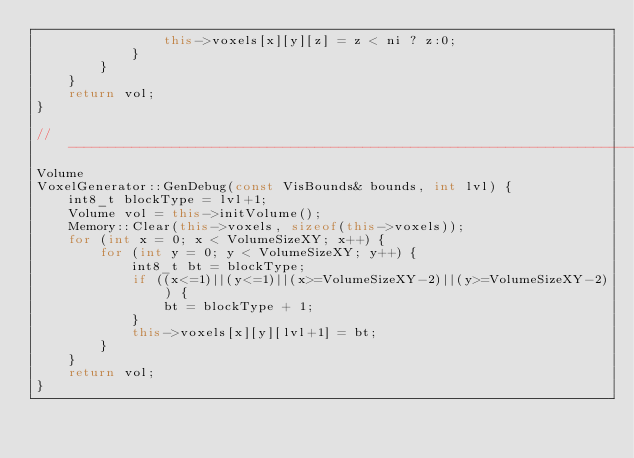<code> <loc_0><loc_0><loc_500><loc_500><_C++_>                this->voxels[x][y][z] = z < ni ? z:0;
            }
        }
    }
    return vol;
}

//------------------------------------------------------------------------------
Volume
VoxelGenerator::GenDebug(const VisBounds& bounds, int lvl) {
    int8_t blockType = lvl+1;
    Volume vol = this->initVolume();
    Memory::Clear(this->voxels, sizeof(this->voxels));
    for (int x = 0; x < VolumeSizeXY; x++) {
        for (int y = 0; y < VolumeSizeXY; y++) {
            int8_t bt = blockType;
            if ((x<=1)||(y<=1)||(x>=VolumeSizeXY-2)||(y>=VolumeSizeXY-2)) {
                bt = blockType + 1;
            }
            this->voxels[x][y][lvl+1] = bt;
        }
    }
    return vol;
}
</code> 